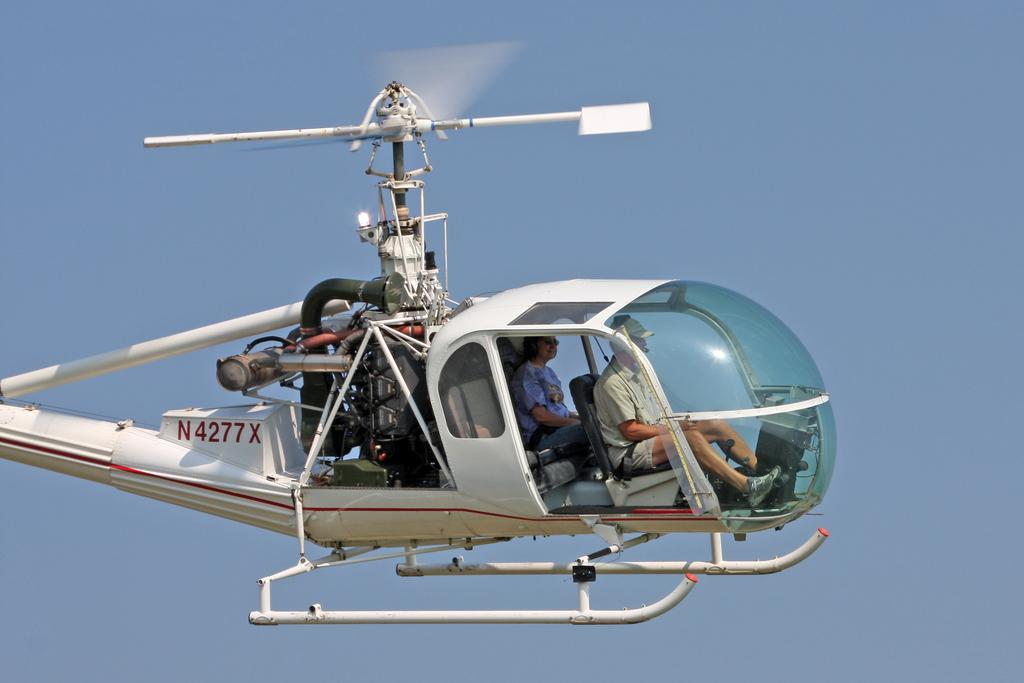<image>
Write a terse but informative summary of the picture. Man navigating a helicopter with the license "N4277X". 